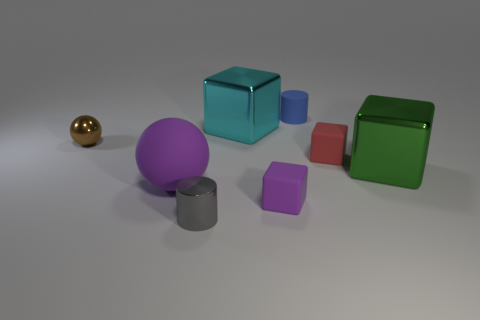Is the number of small matte objects that are behind the tiny red cube the same as the number of gray objects on the right side of the gray object?
Offer a very short reply. No. How many big things are either green metallic things or red matte objects?
Offer a terse response. 1. Are there an equal number of big things in front of the big green metal thing and gray metallic cylinders?
Offer a very short reply. Yes. There is a tiny cylinder that is in front of the small red object; are there any purple matte things that are to the right of it?
Give a very brief answer. Yes. How many other things are there of the same color as the tiny sphere?
Your answer should be compact. 0. What is the color of the small metal cylinder?
Your answer should be compact. Gray. There is a thing that is both on the right side of the tiny purple rubber block and behind the brown metallic ball; what is its size?
Your answer should be compact. Small. How many things are either small cylinders that are behind the small brown thing or large gray matte cubes?
Your answer should be compact. 1. What shape is the red thing that is the same material as the tiny blue object?
Your answer should be very brief. Cube. There is a tiny gray thing; what shape is it?
Your answer should be very brief. Cylinder. 